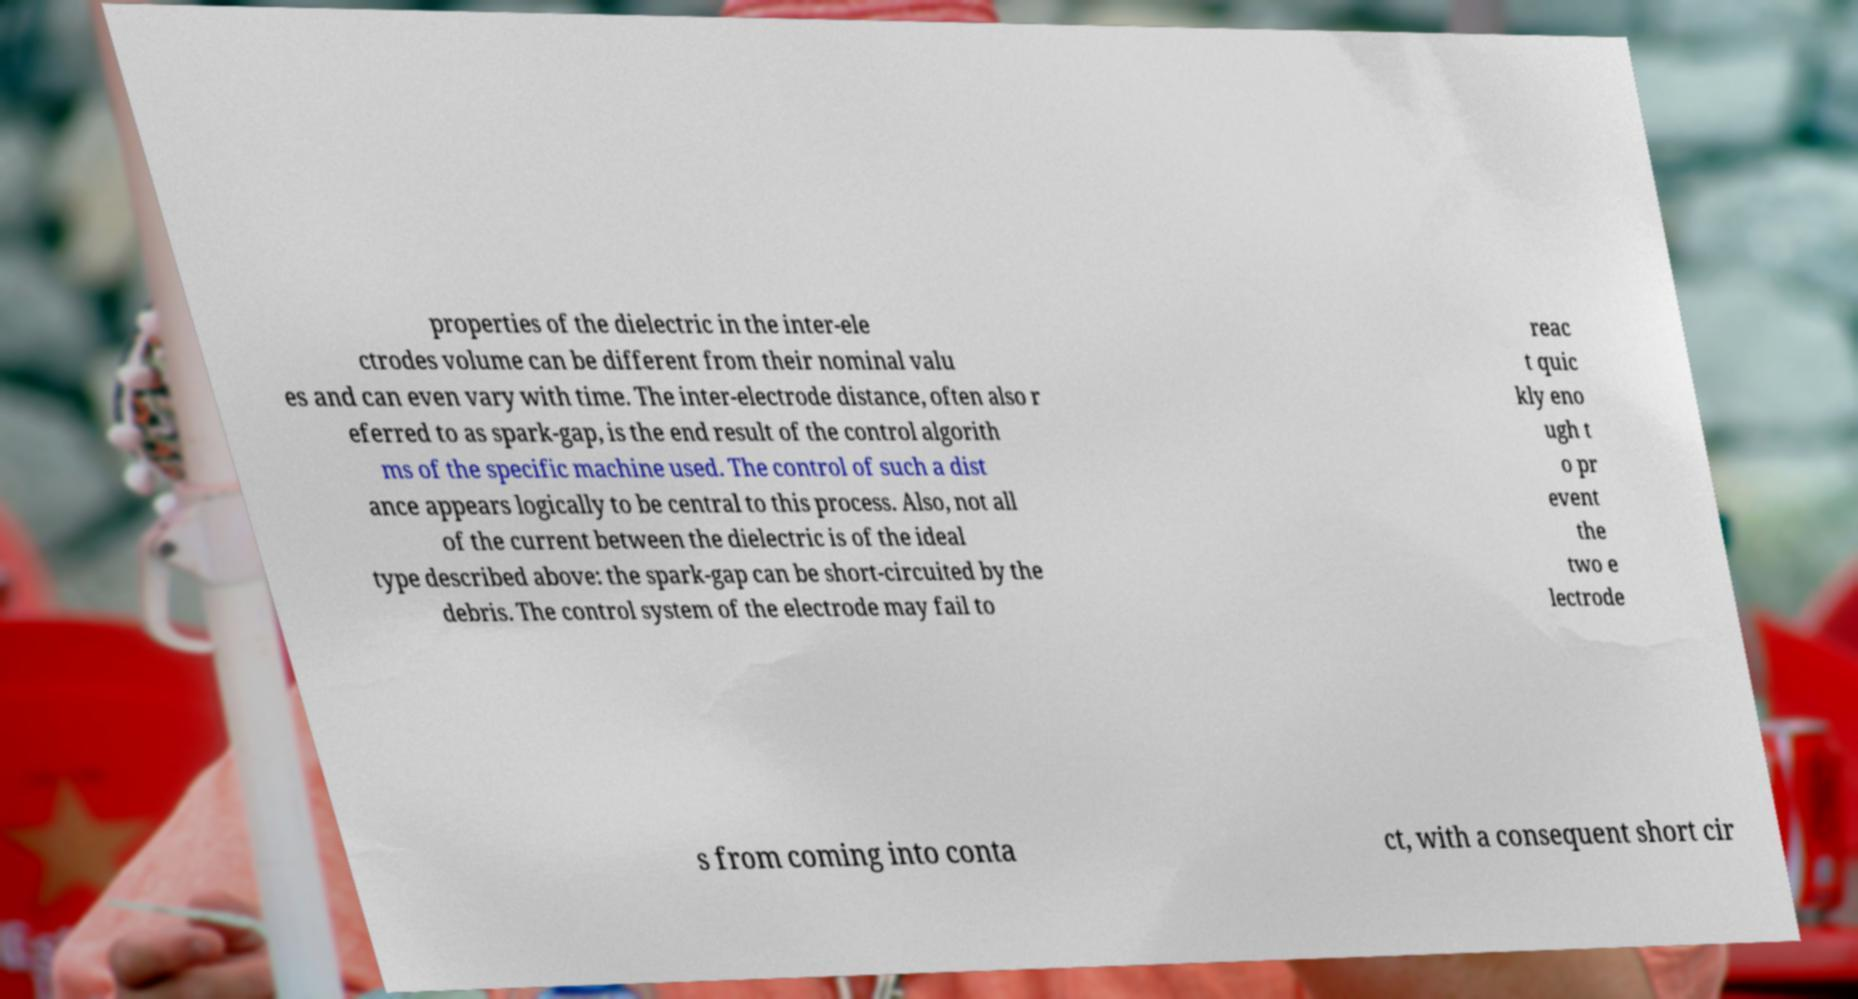Please identify and transcribe the text found in this image. properties of the dielectric in the inter-ele ctrodes volume can be different from their nominal valu es and can even vary with time. The inter-electrode distance, often also r eferred to as spark-gap, is the end result of the control algorith ms of the specific machine used. The control of such a dist ance appears logically to be central to this process. Also, not all of the current between the dielectric is of the ideal type described above: the spark-gap can be short-circuited by the debris. The control system of the electrode may fail to reac t quic kly eno ugh t o pr event the two e lectrode s from coming into conta ct, with a consequent short cir 